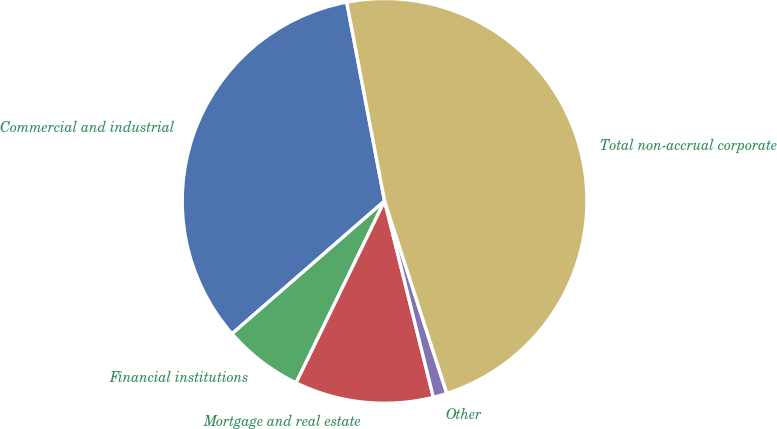Convert chart to OTSL. <chart><loc_0><loc_0><loc_500><loc_500><pie_chart><fcel>Commercial and industrial<fcel>Financial institutions<fcel>Mortgage and real estate<fcel>Other<fcel>Total non-accrual corporate<nl><fcel>33.41%<fcel>6.39%<fcel>11.08%<fcel>1.1%<fcel>48.02%<nl></chart> 